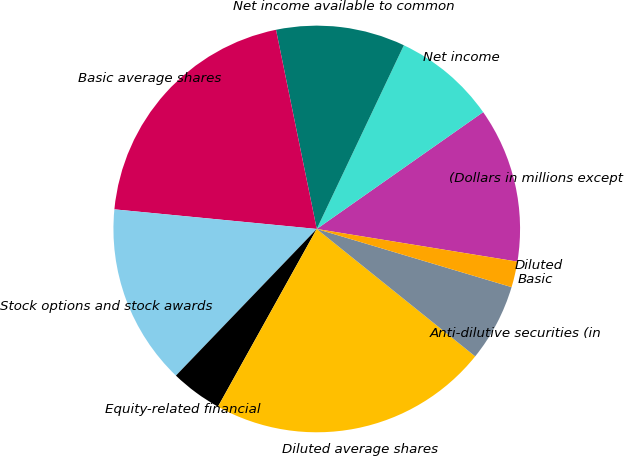Convert chart. <chart><loc_0><loc_0><loc_500><loc_500><pie_chart><fcel>(Dollars in millions except<fcel>Net income<fcel>Net income available to common<fcel>Basic average shares<fcel>Stock options and stock awards<fcel>Equity-related financial<fcel>Diluted average shares<fcel>Anti-dilutive securities (in<fcel>Basic<fcel>Diluted<nl><fcel>12.31%<fcel>8.21%<fcel>10.26%<fcel>20.25%<fcel>14.36%<fcel>4.1%<fcel>22.3%<fcel>6.16%<fcel>2.05%<fcel>0.0%<nl></chart> 